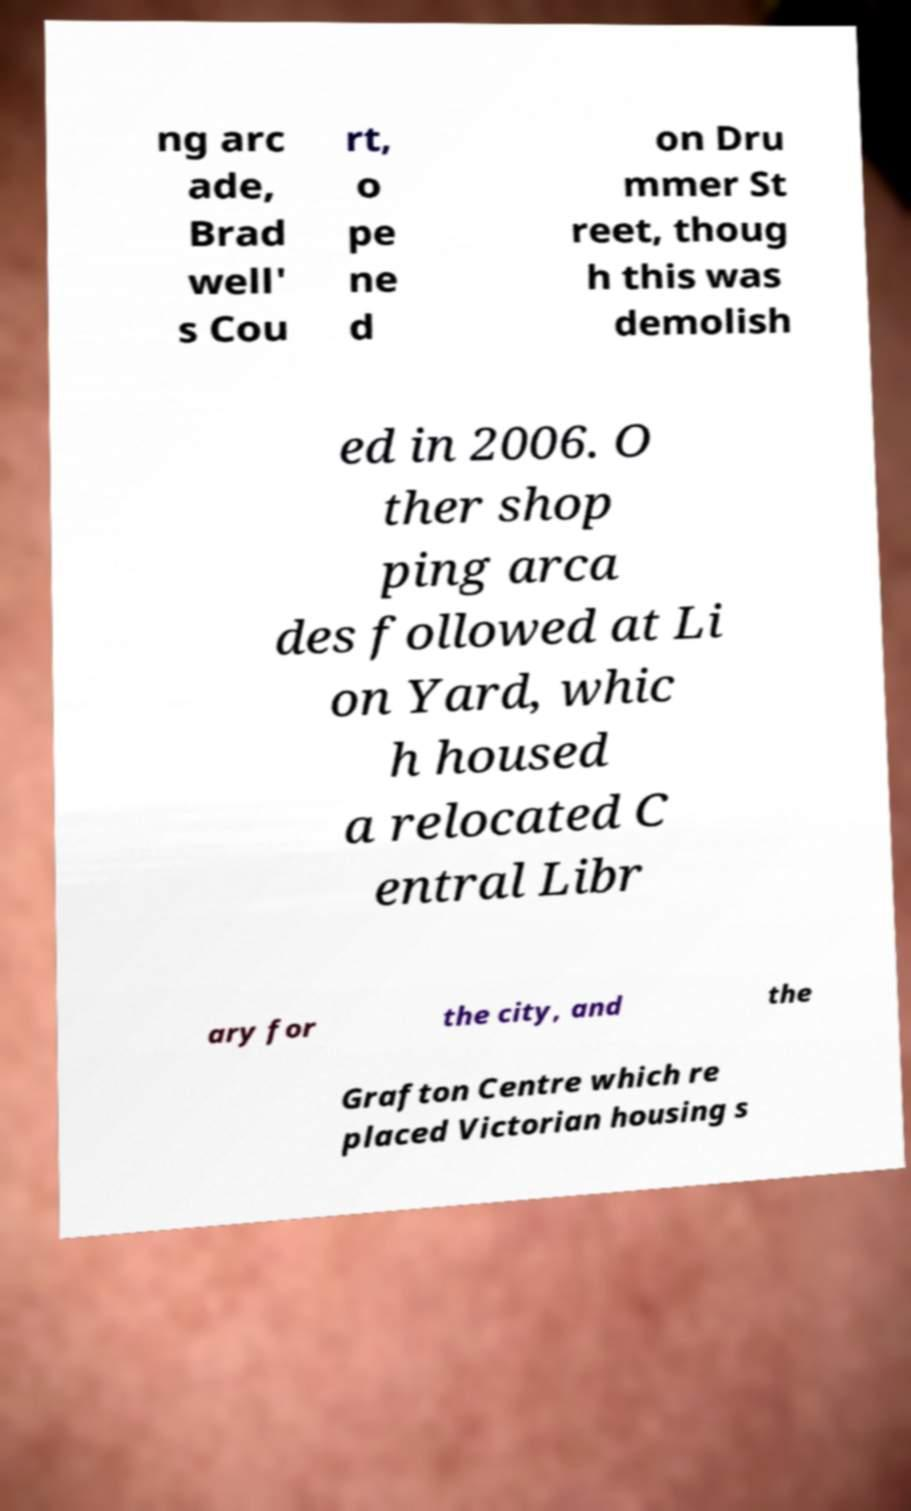For documentation purposes, I need the text within this image transcribed. Could you provide that? ng arc ade, Brad well' s Cou rt, o pe ne d on Dru mmer St reet, thoug h this was demolish ed in 2006. O ther shop ping arca des followed at Li on Yard, whic h housed a relocated C entral Libr ary for the city, and the Grafton Centre which re placed Victorian housing s 